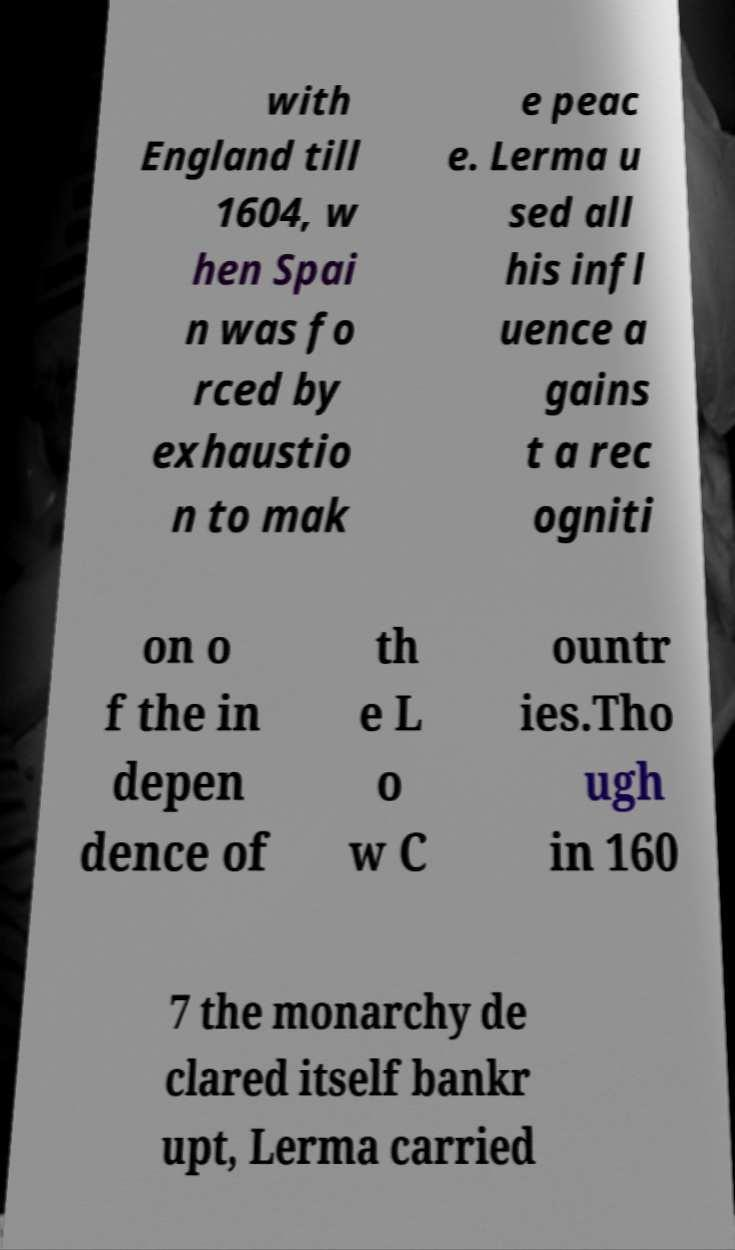Can you accurately transcribe the text from the provided image for me? with England till 1604, w hen Spai n was fo rced by exhaustio n to mak e peac e. Lerma u sed all his infl uence a gains t a rec ogniti on o f the in depen dence of th e L o w C ountr ies.Tho ugh in 160 7 the monarchy de clared itself bankr upt, Lerma carried 